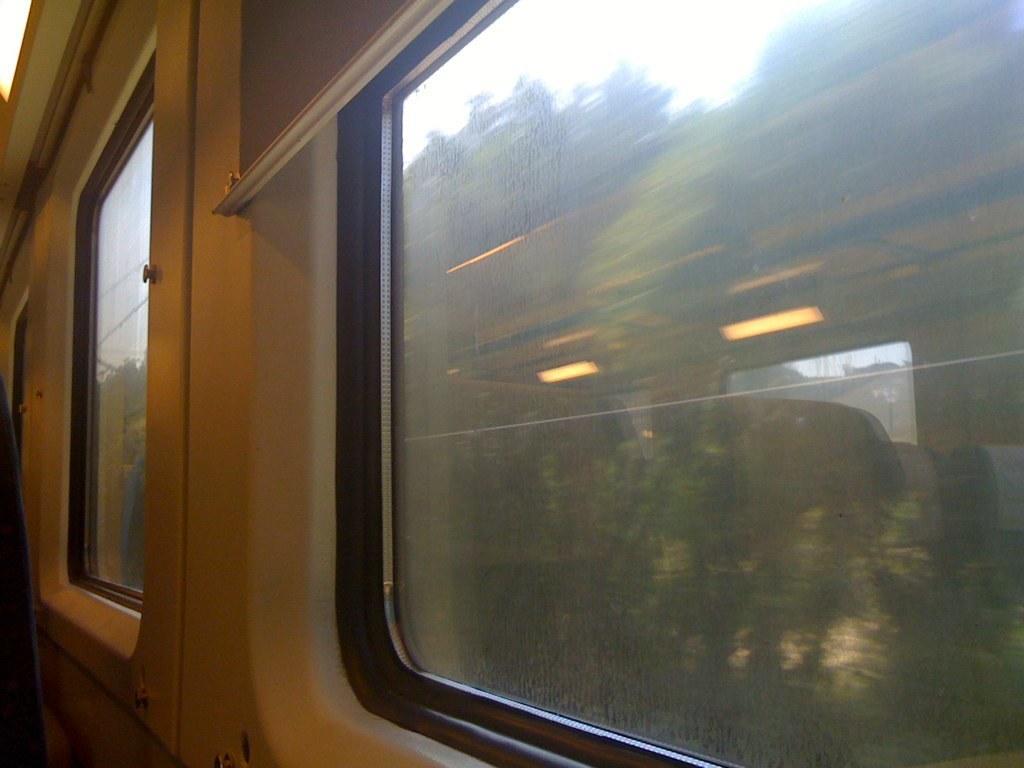How would you summarize this image in a sentence or two? In this picture we can see glass windows and the reflection of the lights, seats, window on the glass and from this glass we can see trees and the sky. 